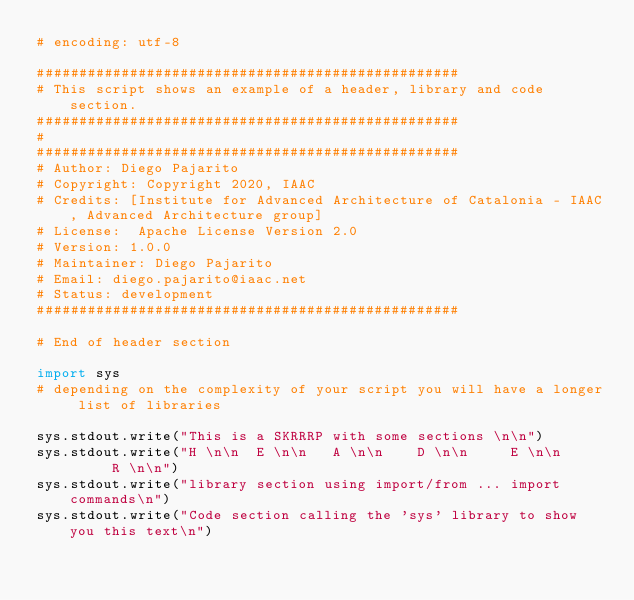<code> <loc_0><loc_0><loc_500><loc_500><_Python_># encoding: utf-8

##################################################
# This script shows an example of a header, library and code section.
##################################################
#
##################################################
# Author: Diego Pajarito
# Copyright: Copyright 2020, IAAC
# Credits: [Institute for Advanced Architecture of Catalonia - IAAC, Advanced Architecture group]
# License:  Apache License Version 2.0
# Version: 1.0.0
# Maintainer: Diego Pajarito
# Email: diego.pajarito@iaac.net
# Status: development
##################################################

# End of header section

import sys
# depending on the complexity of your script you will have a longer list of libraries

sys.stdout.write("This is a SKRRRP with some sections \n\n")
sys.stdout.write("H \n\n  E \n\n   A \n\n    D \n\n     E \n\n      R \n\n")
sys.stdout.write("library section using import/from ... import commands\n")
sys.stdout.write("Code section calling the 'sys' library to show you this text\n")

</code> 